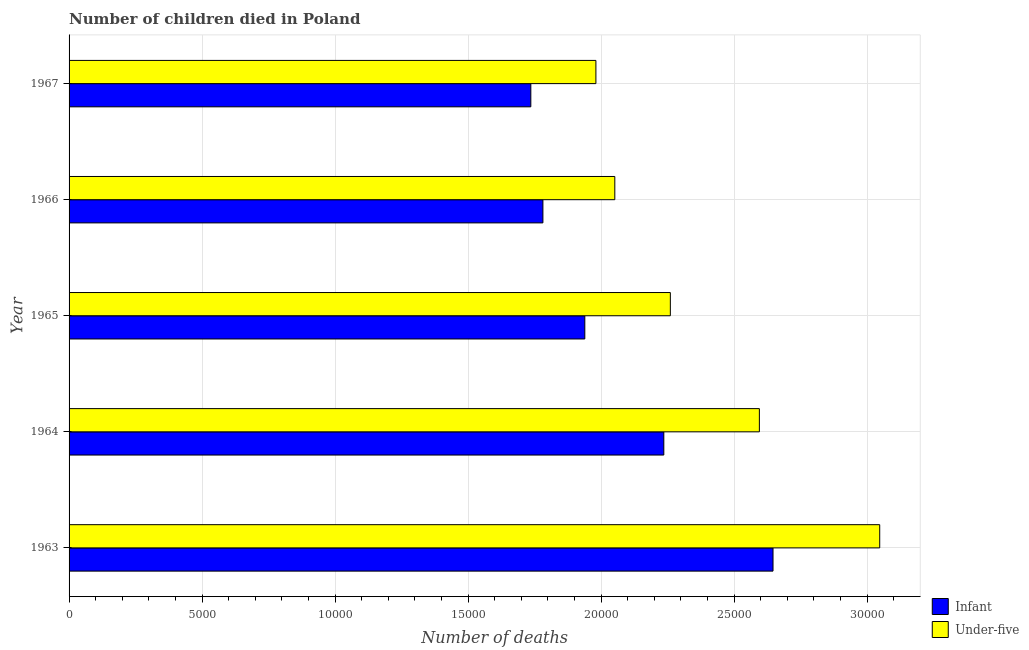How many groups of bars are there?
Keep it short and to the point. 5. Are the number of bars on each tick of the Y-axis equal?
Make the answer very short. Yes. How many bars are there on the 2nd tick from the top?
Your answer should be compact. 2. What is the label of the 4th group of bars from the top?
Ensure brevity in your answer.  1964. In how many cases, is the number of bars for a given year not equal to the number of legend labels?
Offer a terse response. 0. What is the number of under-five deaths in 1966?
Offer a very short reply. 2.05e+04. Across all years, what is the maximum number of infant deaths?
Keep it short and to the point. 2.65e+04. Across all years, what is the minimum number of under-five deaths?
Give a very brief answer. 1.98e+04. In which year was the number of infant deaths maximum?
Provide a succinct answer. 1963. In which year was the number of under-five deaths minimum?
Your answer should be compact. 1967. What is the total number of under-five deaths in the graph?
Your response must be concise. 1.19e+05. What is the difference between the number of infant deaths in 1964 and that in 1967?
Provide a succinct answer. 4999. What is the difference between the number of infant deaths in 1964 and the number of under-five deaths in 1963?
Your response must be concise. -8116. What is the average number of infant deaths per year?
Ensure brevity in your answer.  2.07e+04. In the year 1963, what is the difference between the number of infant deaths and number of under-five deaths?
Keep it short and to the point. -4011. What is the ratio of the number of infant deaths in 1965 to that in 1966?
Your answer should be very brief. 1.09. Is the number of infant deaths in 1965 less than that in 1967?
Keep it short and to the point. No. What is the difference between the highest and the second highest number of under-five deaths?
Offer a very short reply. 4524. What is the difference between the highest and the lowest number of infant deaths?
Give a very brief answer. 9104. In how many years, is the number of infant deaths greater than the average number of infant deaths taken over all years?
Give a very brief answer. 2. What does the 1st bar from the top in 1966 represents?
Your response must be concise. Under-five. What does the 1st bar from the bottom in 1966 represents?
Make the answer very short. Infant. What is the difference between two consecutive major ticks on the X-axis?
Keep it short and to the point. 5000. Does the graph contain any zero values?
Ensure brevity in your answer.  No. How many legend labels are there?
Make the answer very short. 2. How are the legend labels stacked?
Your answer should be compact. Vertical. What is the title of the graph?
Your response must be concise. Number of children died in Poland. Does "Manufacturing industries and construction" appear as one of the legend labels in the graph?
Provide a succinct answer. No. What is the label or title of the X-axis?
Your response must be concise. Number of deaths. What is the label or title of the Y-axis?
Provide a succinct answer. Year. What is the Number of deaths of Infant in 1963?
Give a very brief answer. 2.65e+04. What is the Number of deaths in Under-five in 1963?
Your answer should be compact. 3.05e+04. What is the Number of deaths of Infant in 1964?
Ensure brevity in your answer.  2.24e+04. What is the Number of deaths of Under-five in 1964?
Keep it short and to the point. 2.59e+04. What is the Number of deaths of Infant in 1965?
Offer a terse response. 1.94e+04. What is the Number of deaths of Under-five in 1965?
Ensure brevity in your answer.  2.26e+04. What is the Number of deaths of Infant in 1966?
Provide a succinct answer. 1.78e+04. What is the Number of deaths in Under-five in 1966?
Provide a short and direct response. 2.05e+04. What is the Number of deaths in Infant in 1967?
Provide a succinct answer. 1.74e+04. What is the Number of deaths of Under-five in 1967?
Keep it short and to the point. 1.98e+04. Across all years, what is the maximum Number of deaths in Infant?
Provide a succinct answer. 2.65e+04. Across all years, what is the maximum Number of deaths in Under-five?
Offer a terse response. 3.05e+04. Across all years, what is the minimum Number of deaths in Infant?
Make the answer very short. 1.74e+04. Across all years, what is the minimum Number of deaths in Under-five?
Offer a terse response. 1.98e+04. What is the total Number of deaths of Infant in the graph?
Offer a terse response. 1.03e+05. What is the total Number of deaths of Under-five in the graph?
Offer a very short reply. 1.19e+05. What is the difference between the Number of deaths of Infant in 1963 and that in 1964?
Give a very brief answer. 4105. What is the difference between the Number of deaths in Under-five in 1963 and that in 1964?
Keep it short and to the point. 4524. What is the difference between the Number of deaths of Infant in 1963 and that in 1965?
Your answer should be compact. 7075. What is the difference between the Number of deaths in Under-five in 1963 and that in 1965?
Your answer should be compact. 7871. What is the difference between the Number of deaths of Infant in 1963 and that in 1966?
Give a very brief answer. 8650. What is the difference between the Number of deaths of Under-five in 1963 and that in 1966?
Make the answer very short. 9958. What is the difference between the Number of deaths of Infant in 1963 and that in 1967?
Offer a terse response. 9104. What is the difference between the Number of deaths in Under-five in 1963 and that in 1967?
Your answer should be very brief. 1.07e+04. What is the difference between the Number of deaths of Infant in 1964 and that in 1965?
Your response must be concise. 2970. What is the difference between the Number of deaths in Under-five in 1964 and that in 1965?
Give a very brief answer. 3347. What is the difference between the Number of deaths of Infant in 1964 and that in 1966?
Provide a succinct answer. 4545. What is the difference between the Number of deaths of Under-five in 1964 and that in 1966?
Offer a very short reply. 5434. What is the difference between the Number of deaths in Infant in 1964 and that in 1967?
Keep it short and to the point. 4999. What is the difference between the Number of deaths of Under-five in 1964 and that in 1967?
Your response must be concise. 6145. What is the difference between the Number of deaths in Infant in 1965 and that in 1966?
Make the answer very short. 1575. What is the difference between the Number of deaths of Under-five in 1965 and that in 1966?
Your response must be concise. 2087. What is the difference between the Number of deaths of Infant in 1965 and that in 1967?
Provide a short and direct response. 2029. What is the difference between the Number of deaths in Under-five in 1965 and that in 1967?
Offer a very short reply. 2798. What is the difference between the Number of deaths in Infant in 1966 and that in 1967?
Your answer should be very brief. 454. What is the difference between the Number of deaths in Under-five in 1966 and that in 1967?
Give a very brief answer. 711. What is the difference between the Number of deaths of Infant in 1963 and the Number of deaths of Under-five in 1964?
Make the answer very short. 513. What is the difference between the Number of deaths of Infant in 1963 and the Number of deaths of Under-five in 1965?
Your response must be concise. 3860. What is the difference between the Number of deaths of Infant in 1963 and the Number of deaths of Under-five in 1966?
Your response must be concise. 5947. What is the difference between the Number of deaths of Infant in 1963 and the Number of deaths of Under-five in 1967?
Your answer should be very brief. 6658. What is the difference between the Number of deaths in Infant in 1964 and the Number of deaths in Under-five in 1965?
Make the answer very short. -245. What is the difference between the Number of deaths of Infant in 1964 and the Number of deaths of Under-five in 1966?
Keep it short and to the point. 1842. What is the difference between the Number of deaths in Infant in 1964 and the Number of deaths in Under-five in 1967?
Keep it short and to the point. 2553. What is the difference between the Number of deaths of Infant in 1965 and the Number of deaths of Under-five in 1966?
Provide a short and direct response. -1128. What is the difference between the Number of deaths in Infant in 1965 and the Number of deaths in Under-five in 1967?
Offer a terse response. -417. What is the difference between the Number of deaths of Infant in 1966 and the Number of deaths of Under-five in 1967?
Your answer should be compact. -1992. What is the average Number of deaths of Infant per year?
Give a very brief answer. 2.07e+04. What is the average Number of deaths of Under-five per year?
Your answer should be compact. 2.39e+04. In the year 1963, what is the difference between the Number of deaths of Infant and Number of deaths of Under-five?
Your response must be concise. -4011. In the year 1964, what is the difference between the Number of deaths of Infant and Number of deaths of Under-five?
Offer a terse response. -3592. In the year 1965, what is the difference between the Number of deaths in Infant and Number of deaths in Under-five?
Make the answer very short. -3215. In the year 1966, what is the difference between the Number of deaths in Infant and Number of deaths in Under-five?
Provide a short and direct response. -2703. In the year 1967, what is the difference between the Number of deaths of Infant and Number of deaths of Under-five?
Your answer should be compact. -2446. What is the ratio of the Number of deaths of Infant in 1963 to that in 1964?
Ensure brevity in your answer.  1.18. What is the ratio of the Number of deaths of Under-five in 1963 to that in 1964?
Your answer should be very brief. 1.17. What is the ratio of the Number of deaths in Infant in 1963 to that in 1965?
Ensure brevity in your answer.  1.36. What is the ratio of the Number of deaths of Under-five in 1963 to that in 1965?
Your response must be concise. 1.35. What is the ratio of the Number of deaths of Infant in 1963 to that in 1966?
Your response must be concise. 1.49. What is the ratio of the Number of deaths in Under-five in 1963 to that in 1966?
Provide a succinct answer. 1.49. What is the ratio of the Number of deaths of Infant in 1963 to that in 1967?
Make the answer very short. 1.52. What is the ratio of the Number of deaths in Under-five in 1963 to that in 1967?
Ensure brevity in your answer.  1.54. What is the ratio of the Number of deaths in Infant in 1964 to that in 1965?
Provide a short and direct response. 1.15. What is the ratio of the Number of deaths in Under-five in 1964 to that in 1965?
Your response must be concise. 1.15. What is the ratio of the Number of deaths of Infant in 1964 to that in 1966?
Give a very brief answer. 1.26. What is the ratio of the Number of deaths in Under-five in 1964 to that in 1966?
Your response must be concise. 1.26. What is the ratio of the Number of deaths in Infant in 1964 to that in 1967?
Keep it short and to the point. 1.29. What is the ratio of the Number of deaths in Under-five in 1964 to that in 1967?
Offer a terse response. 1.31. What is the ratio of the Number of deaths of Infant in 1965 to that in 1966?
Make the answer very short. 1.09. What is the ratio of the Number of deaths of Under-five in 1965 to that in 1966?
Offer a very short reply. 1.1. What is the ratio of the Number of deaths of Infant in 1965 to that in 1967?
Keep it short and to the point. 1.12. What is the ratio of the Number of deaths in Under-five in 1965 to that in 1967?
Your response must be concise. 1.14. What is the ratio of the Number of deaths of Infant in 1966 to that in 1967?
Provide a succinct answer. 1.03. What is the ratio of the Number of deaths of Under-five in 1966 to that in 1967?
Give a very brief answer. 1.04. What is the difference between the highest and the second highest Number of deaths of Infant?
Ensure brevity in your answer.  4105. What is the difference between the highest and the second highest Number of deaths in Under-five?
Ensure brevity in your answer.  4524. What is the difference between the highest and the lowest Number of deaths in Infant?
Offer a very short reply. 9104. What is the difference between the highest and the lowest Number of deaths of Under-five?
Ensure brevity in your answer.  1.07e+04. 